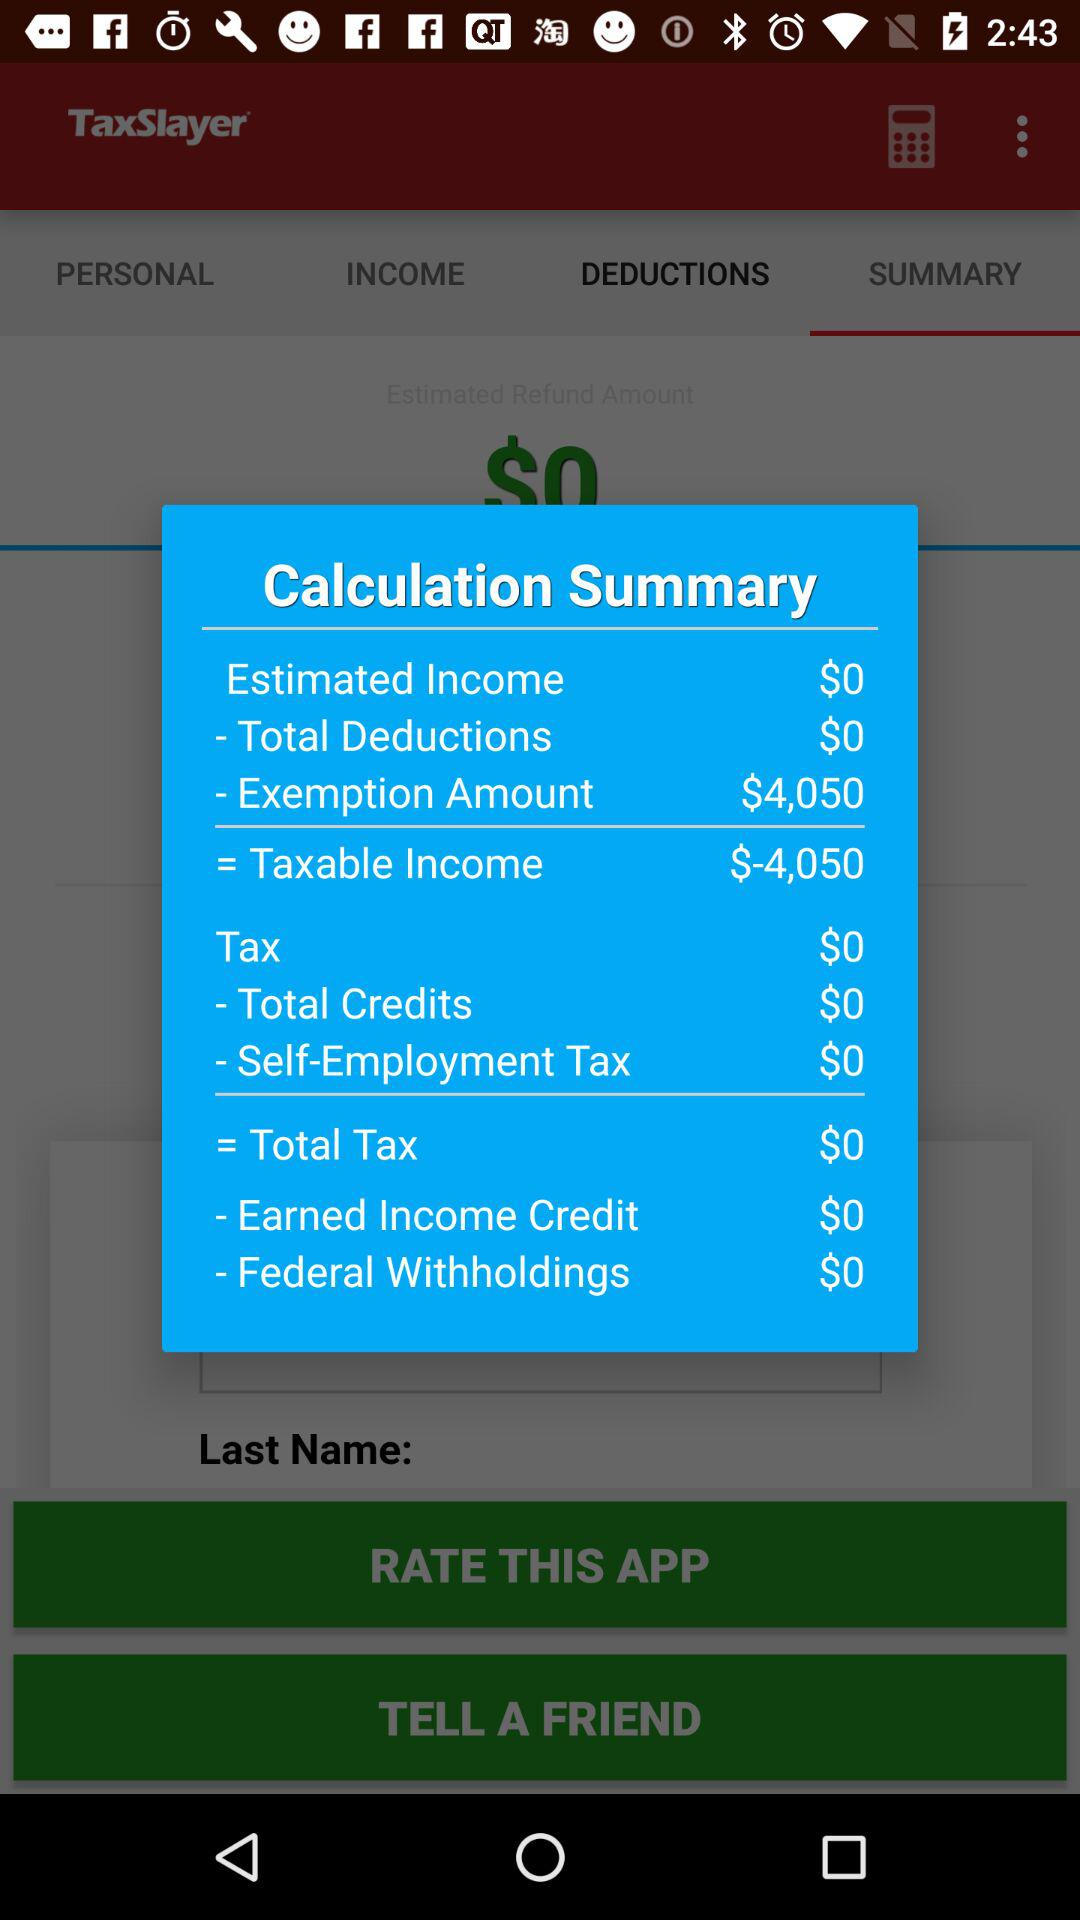What is the exemption amount? The exemption amount is $4050. 